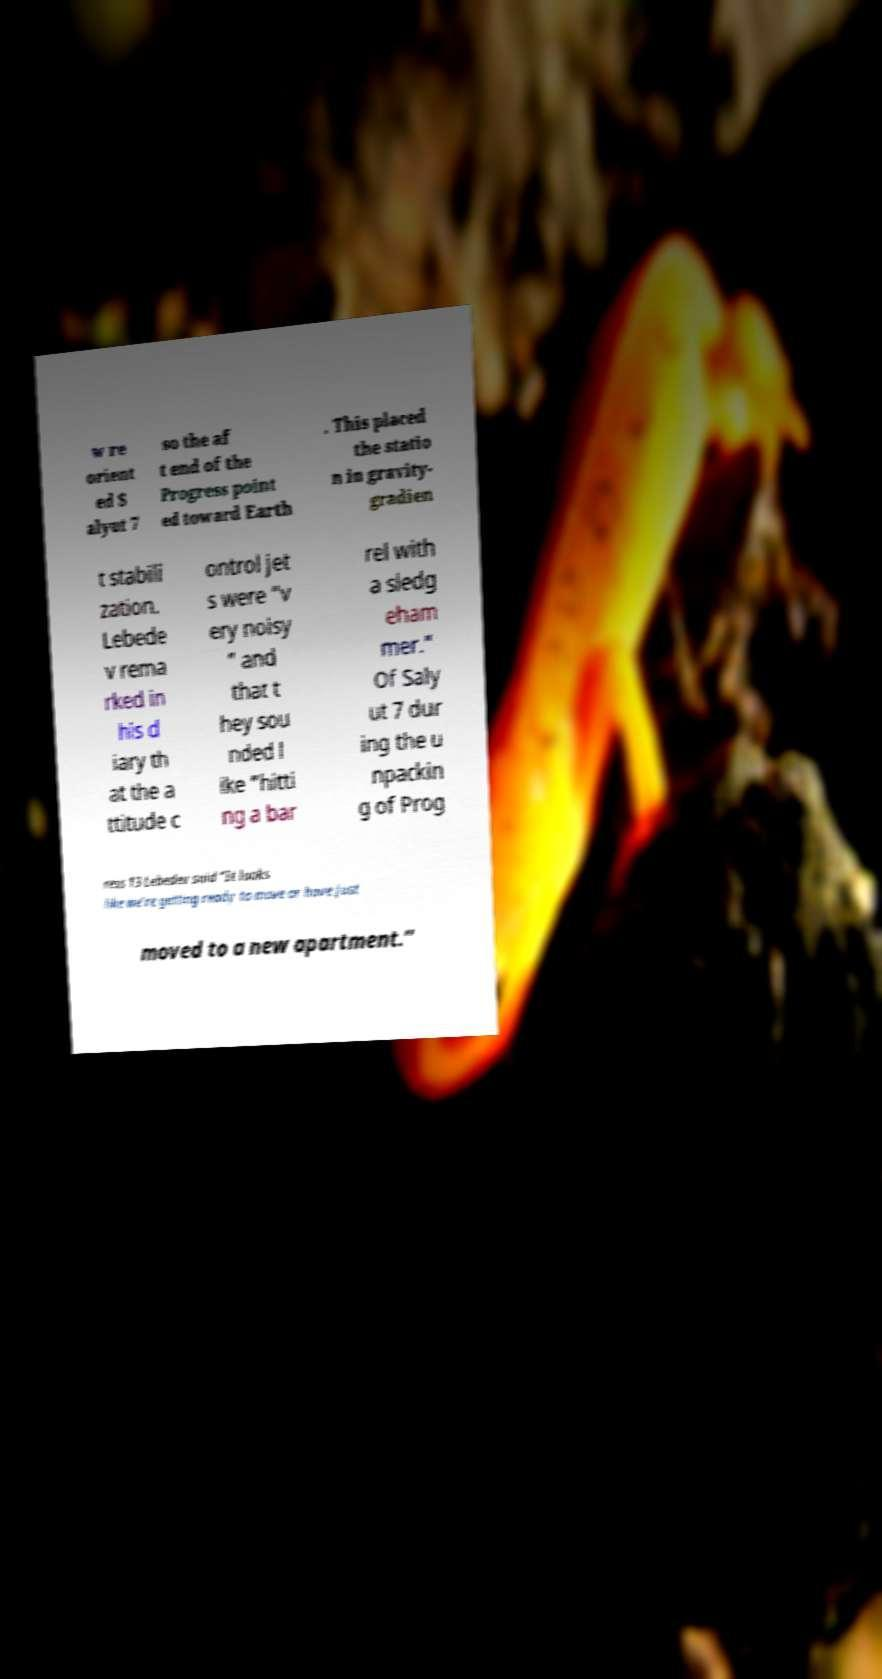Could you extract and type out the text from this image? w re orient ed S alyut 7 so the af t end of the Progress point ed toward Earth . This placed the statio n in gravity- gradien t stabili zation. Lebede v rema rked in his d iary th at the a ttitude c ontrol jet s were “v ery noisy ” and that t hey sou nded l ike “hitti ng a bar rel with a sledg eham mer.” Of Saly ut 7 dur ing the u npackin g of Prog ress 13 Lebedev said “It looks like we’re getting ready to move or have just moved to a new apartment.” 